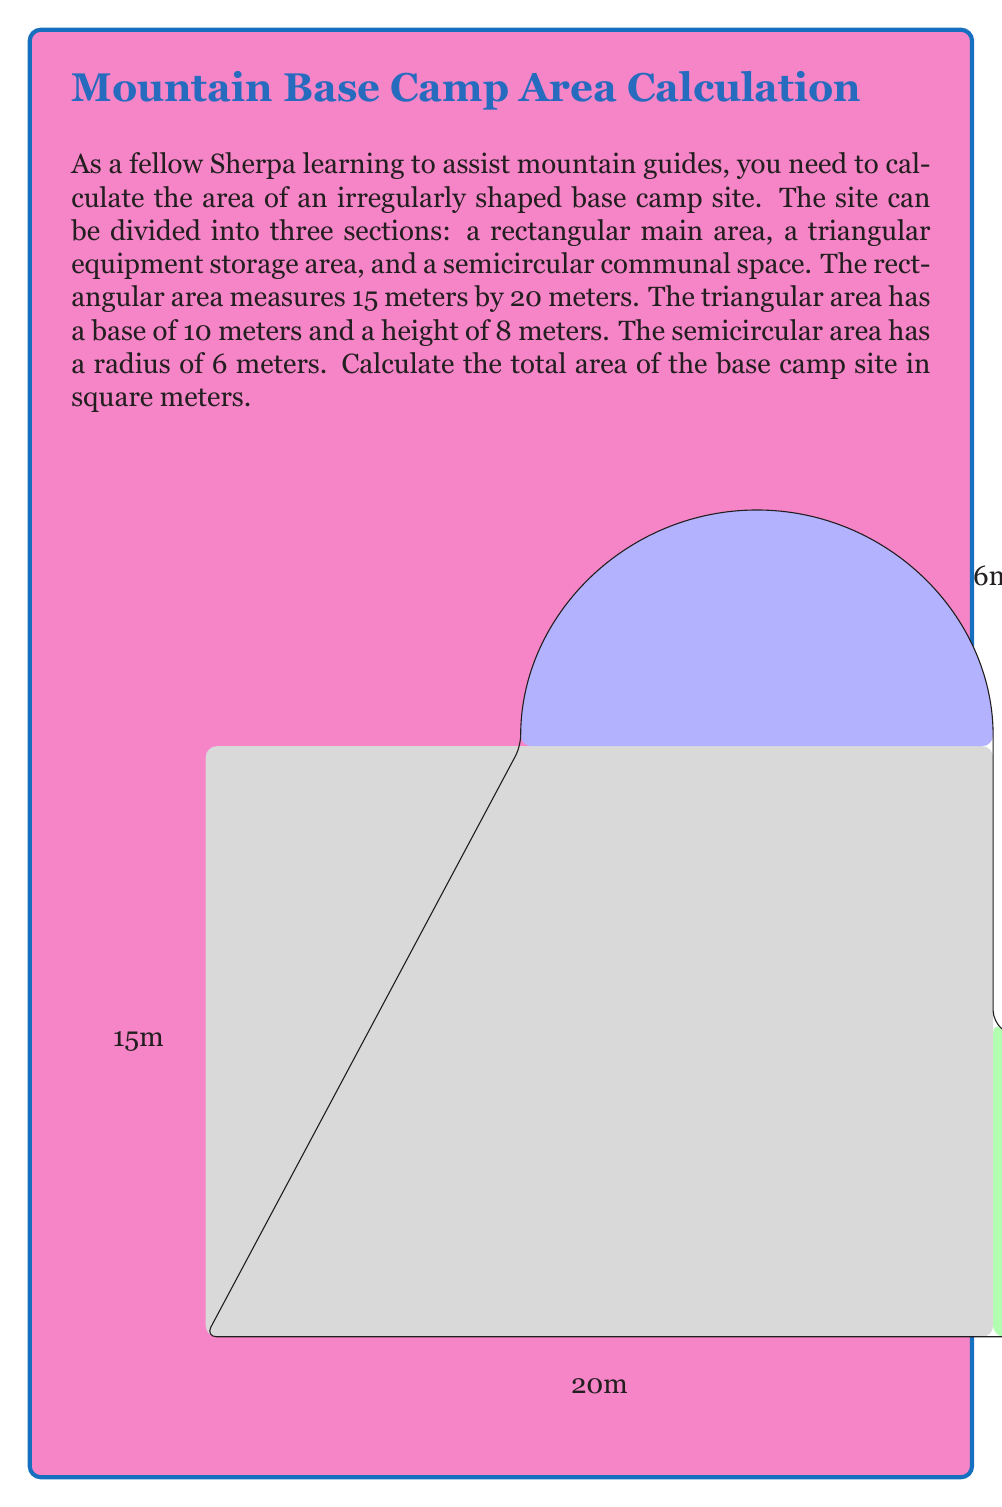Provide a solution to this math problem. To find the total area of the irregularly shaped base camp site, we need to calculate the areas of each section and then sum them up.

1. Rectangular main area:
   $$ A_{rectangle} = length \times width = 20 \text{ m} \times 15 \text{ m} = 300 \text{ m}^2 $$

2. Triangular equipment storage area:
   $$ A_{triangle} = \frac{1}{2} \times base \times height = \frac{1}{2} \times 10 \text{ m} \times 8 \text{ m} = 40 \text{ m}^2 $$

3. Semicircular communal space:
   The area of a semicircle is half the area of a full circle.
   $$ A_{semicircle} = \frac{1}{2} \times \pi r^2 = \frac{1}{2} \times \pi \times (6 \text{ m})^2 = 18\pi \text{ m}^2 $$

Now, we sum up all the areas to get the total area of the base camp site:

$$ A_{total} = A_{rectangle} + A_{triangle} + A_{semicircle} $$
$$ A_{total} = 300 \text{ m}^2 + 40 \text{ m}^2 + 18\pi \text{ m}^2 $$
$$ A_{total} = 340 + 18\pi \text{ m}^2 $$
$$ A_{total} \approx 396.55 \text{ m}^2 $$
Answer: The total area of the base camp site is $340 + 18\pi \text{ m}^2$ or approximately $396.55 \text{ m}^2$. 